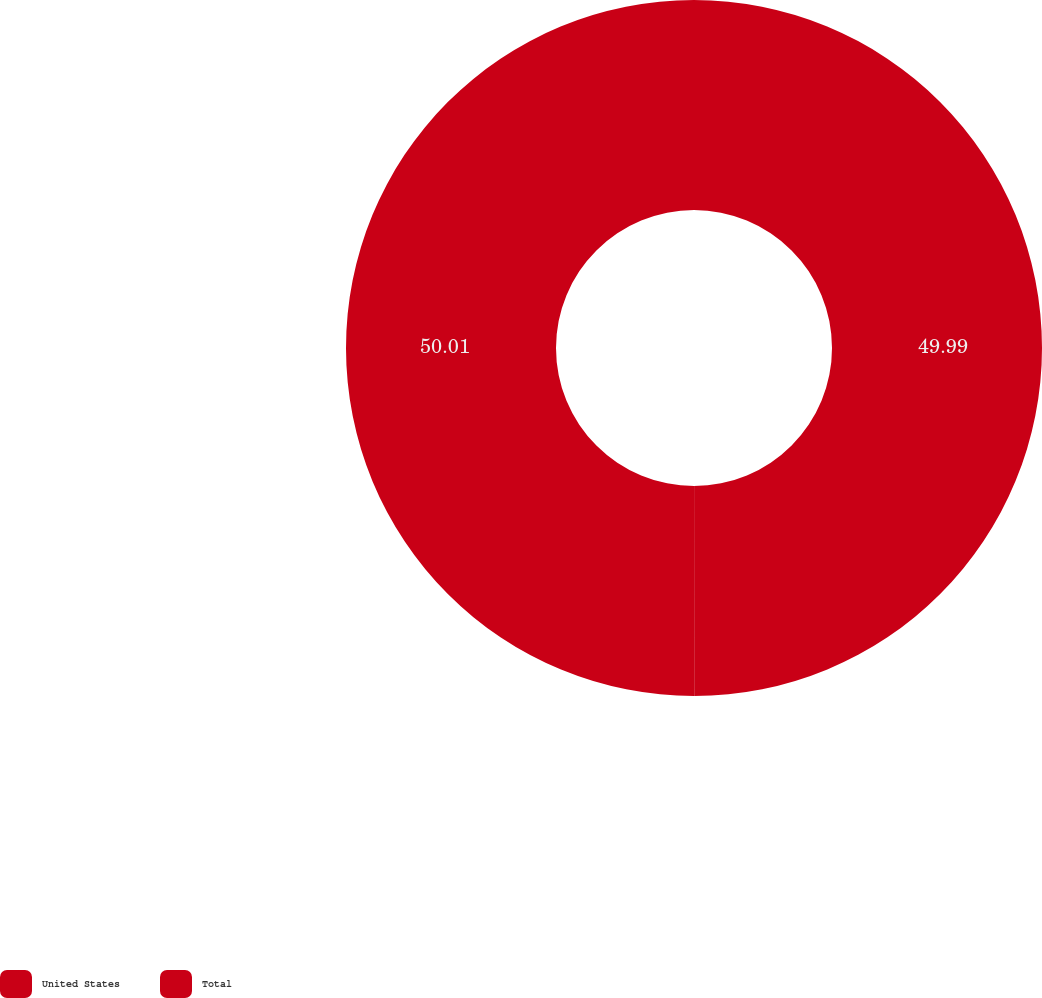Convert chart to OTSL. <chart><loc_0><loc_0><loc_500><loc_500><pie_chart><fcel>United States<fcel>Total<nl><fcel>49.99%<fcel>50.01%<nl></chart> 